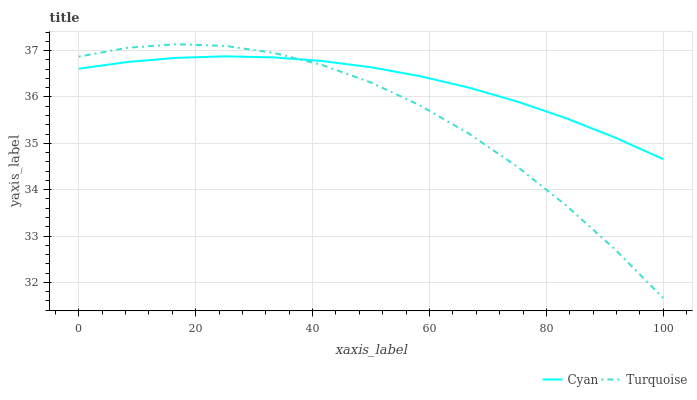Does Turquoise have the maximum area under the curve?
Answer yes or no. No. Is Turquoise the smoothest?
Answer yes or no. No. 